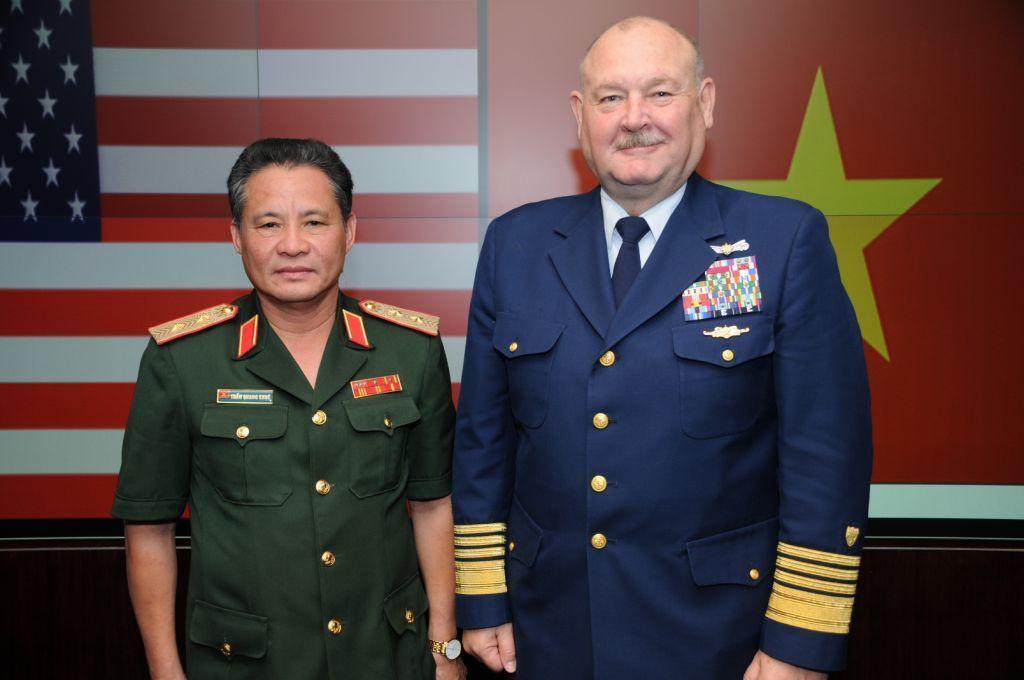Describe this image in one or two sentences. In this image there are two men standing, in the background there are flags. 